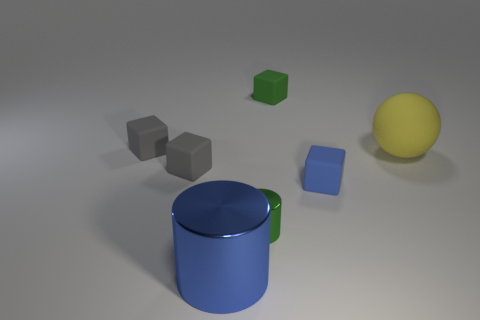How many cubes are either big things or blue shiny objects?
Your response must be concise. 0. Is there a gray rubber object that has the same shape as the blue metal object?
Your answer should be compact. No. How many other objects are there of the same color as the large sphere?
Keep it short and to the point. 0. Are there fewer blocks in front of the tiny green cylinder than blue things?
Keep it short and to the point. Yes. What number of gray cubes are there?
Give a very brief answer. 2. What number of large blue objects have the same material as the blue block?
Ensure brevity in your answer.  0. What number of objects are either things left of the big shiny object or big things?
Keep it short and to the point. 4. Is the number of yellow matte balls in front of the large blue shiny thing less than the number of big yellow rubber spheres to the left of the large yellow matte sphere?
Keep it short and to the point. No. There is a tiny green metal object; are there any large yellow matte objects behind it?
Keep it short and to the point. Yes. What number of objects are either rubber things that are on the right side of the blue shiny thing or tiny rubber cubes left of the small blue cube?
Your response must be concise. 5. 